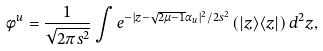Convert formula to latex. <formula><loc_0><loc_0><loc_500><loc_500>\phi ^ { u } = \frac { 1 } { \sqrt { 2 \pi s ^ { 2 } } } \int e ^ { - | { z } - \sqrt { 2 \mu - 1 } \alpha _ { u } | ^ { 2 } / 2 s ^ { 2 } } \left ( | { z } \rangle \langle { z } | \right ) d ^ { 2 } { z } ,</formula> 